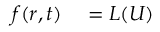Convert formula to latex. <formula><loc_0><loc_0><loc_500><loc_500>\begin{array} { r l } { f ( r , t ) } & = L ( U ) } \end{array}</formula> 